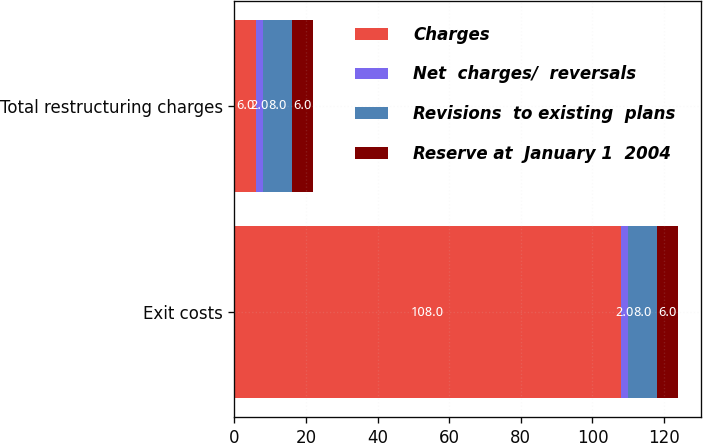Convert chart to OTSL. <chart><loc_0><loc_0><loc_500><loc_500><stacked_bar_chart><ecel><fcel>Exit costs<fcel>Total restructuring charges<nl><fcel>Charges<fcel>108<fcel>6<nl><fcel>Net  charges/  reversals<fcel>2<fcel>2<nl><fcel>Revisions  to existing  plans<fcel>8<fcel>8<nl><fcel>Reserve at  January 1  2004<fcel>6<fcel>6<nl></chart> 